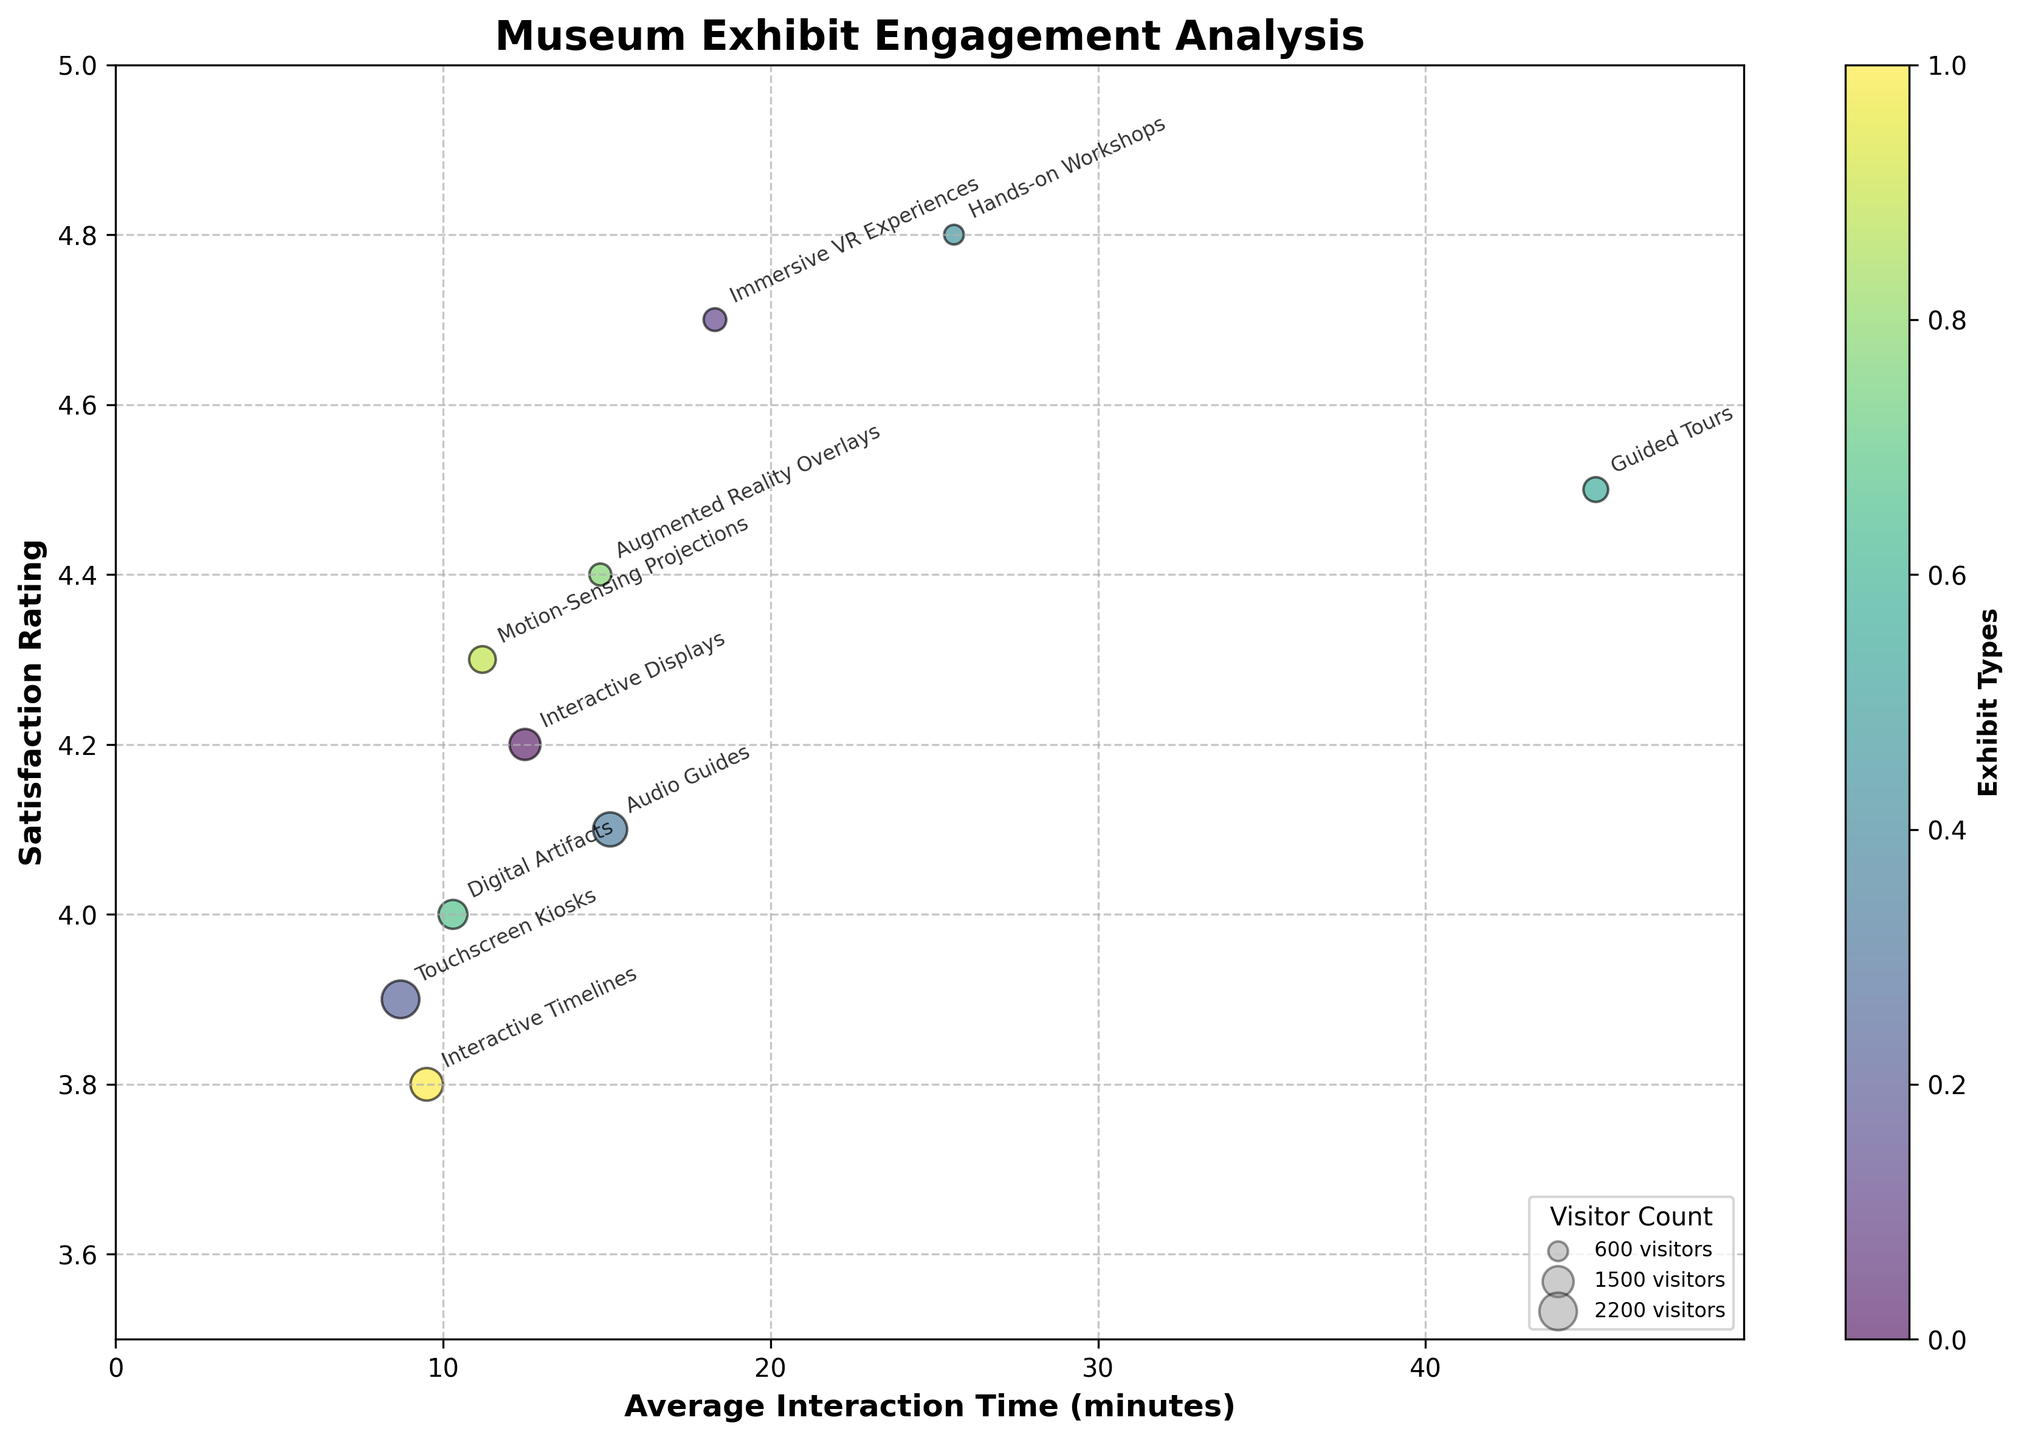What is the title of the figure? The title is located at the top of the figure and provides an overview of what the plot represents. In this case, it is "Museum Exhibit Engagement Analysis".
Answer: Museum Exhibit Engagement Analysis What does the x-axis represent? The label along the x-axis indicates what variable is being measured. Here, it is "Average Interaction Time (minutes)" as noted next to the axis.
Answer: Average Interaction Time (minutes) Which exhibit type has the highest satisfaction rating? Look at the y-axis, which represents Satisfaction Rating, and identify the highest plotted value. The label for this point is "Hands-on Workshops" with a rating of 4.8.
Answer: Hands-on Workshops What is the average interaction time for Guided Tours? The exhibit type Guided Tours is labeled on the plot. Find the x-axis value for this point, which is close to 45.2 minutes.
Answer: 45.2 minutes How many visitors interacted with the Digital Artifacts exhibit? The size of each bubble represents the visitor count. The figure legend indicates this scale, and Digital Artifacts has a medium-sized bubble, equating to 1300 visitors as listed in the data.
Answer: 1300 Which exhibit type has a higher satisfaction rating, Touchscreen Kiosks or Interactive Timelines? Compare the y-axis values for Touchscreen Kiosks (3.9) and Interactive Timelines (3.8). Touchscreen Kiosks has a slightly higher rating.
Answer: Touchscreen Kiosks Calculate the difference in average interaction time between Immersive VR Experiences and Motion-Sensing Projections. The average interaction time for Immersive VR Experiences is 18.3 minutes and for Motion-Sensing Projections is 11.2 minutes. Subtract 11.2 from 18.3 to get 7.1 minutes.
Answer: 7.1 minutes Which exhibit type has both high satisfaction ratings and high visitor counts? Look for bubbles that are larger and higher on the y-axis. Hands-on Workshops has a high satisfaction rating (4.8) and a fairly large visitor count (600).
Answer: Hands-on Workshops What is the color scheme used in the plot? The plot uses a gradient color scheme ranging from light to dark colors such as light green to dark blue-purple, representing different exhibit types.
Answer: Gradient from light green to dark blue-purple Compare the satisfaction rating of Augmented Reality Overlays to that of Audio Guides. Augmented Reality Overlays have a satisfaction rating of 4.4, while Audio Guides have a satisfaction rating of 4.1. Augmented Reality Overlays have a higher satisfaction rating.
Answer: Augmented Reality Overlays How is the visitor count indicated in the plot? The visitor count is indicated by the size of the bubbles, with larger bubbles representing higher visitor counts as clarified in the legend.
Answer: Size of the bubbles For which exhibit type is the visitor count just over 1800? The legend helps identify visitor counts, and searching the plot for a bubble just larger than the 1800 marker points to the exhibit Audio Guides.
Answer: Audio Guides What is the typical satisfaction rating range shown in the plot? The y-axis scale shows the satisfaction ratings range from about 3.5 to 5. This represents the extent of satisfaction ratings plotted.
Answer: About 3.5 to 5 